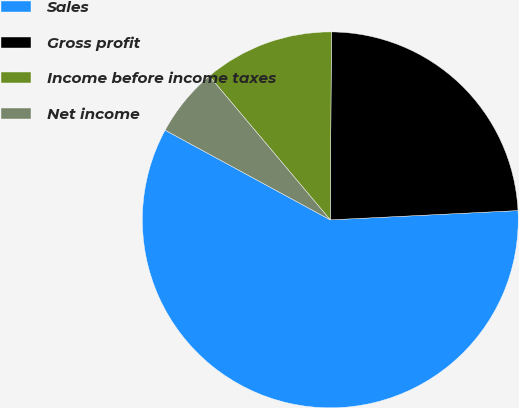Convert chart. <chart><loc_0><loc_0><loc_500><loc_500><pie_chart><fcel>Sales<fcel>Gross profit<fcel>Income before income taxes<fcel>Net income<nl><fcel>58.71%<fcel>24.12%<fcel>11.23%<fcel>5.95%<nl></chart> 